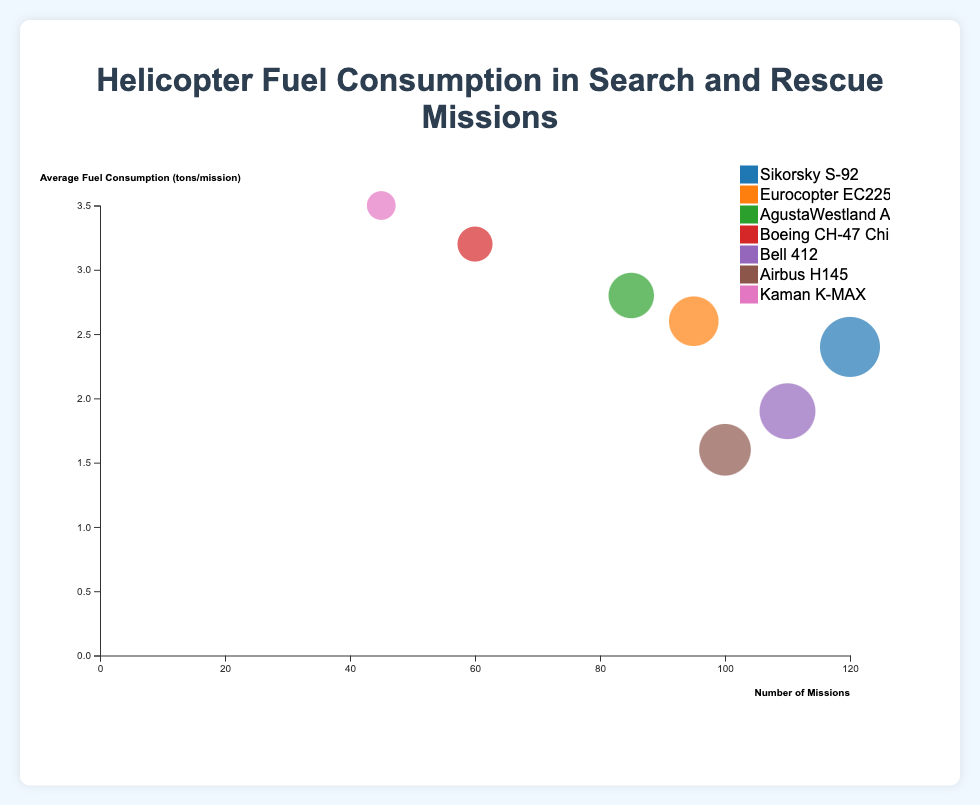What is the title of the chart? The title can be found at the top of the chart. It provides a brief description of the visualized data.
Answer: Helicopter Fuel Consumption in Search and Rescue Missions Which helicopter model has the highest number of missions? By looking at the x-axis, you can see that the model with the bubble farthest to the right represents the highest number of missions.
Answer: Sikorsky S-92 What is the average fuel consumption per mission for the AgustaWestland AW189? Find the bubble corresponding to AgustaWestland AW189 and look at its position on the y-axis.
Answer: 2.8 tons/mission Which helicopter model has the lowest average fuel consumption per mission? By looking at the y-axis, see which bubble is positioned the lowest.
Answer: Airbus H145 How many helicopter models have an average fuel consumption per mission greater than 3 tons? Identify the bubbles above the 3-ton mark on the y-axis and count them.
Answer: 2 Which helicopter model has both low missions and high average fuel consumption per mission? Look for a small-sized bubble positioned high on the y-axis (indicating fewer missions but higher fuel consumption).
Answer: Kaman K-MAX Which helicopter model is the most efficient in terms of fuel consumption per mission given it has a relatively high number of missions? Find a model that has a relatively high x-position with a low y-position.
Answer: Airbus H145 Compare the number of missions between the Bell 412 and Eurocopter EC225. Which one has more missions and by how much? Look at the x-axis positions for Bell 412 and Eurocopter EC225 and find the difference.
Answer: Bell 412 has 15 more missions What is the combined total number of missions for the helicopter models with fuel consumption above 2.5 tons/mission? Identify models with bubbles above the 2.5 mark on the y-axis, sum their missions from the x-axis.
Answer: 285 How does the size of the bubble relate to the data? The size of the bubble represents the number of missions; larger bubbles indicate more missions.
Answer: More missions → Larger bubble 